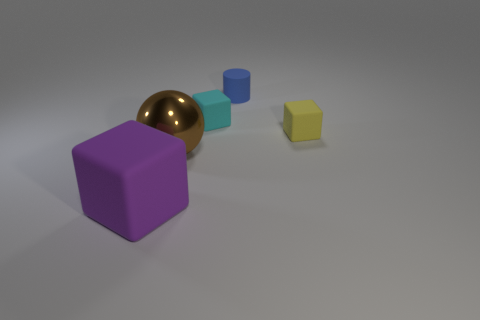Can you tell the relative sizes of these objects? Certainly, the purple cube is the largest object in the image, the golden sphere appears to be the second largest, and the cyan cube is smaller than the sphere but larger than the yellow cube, which is the smallest. 